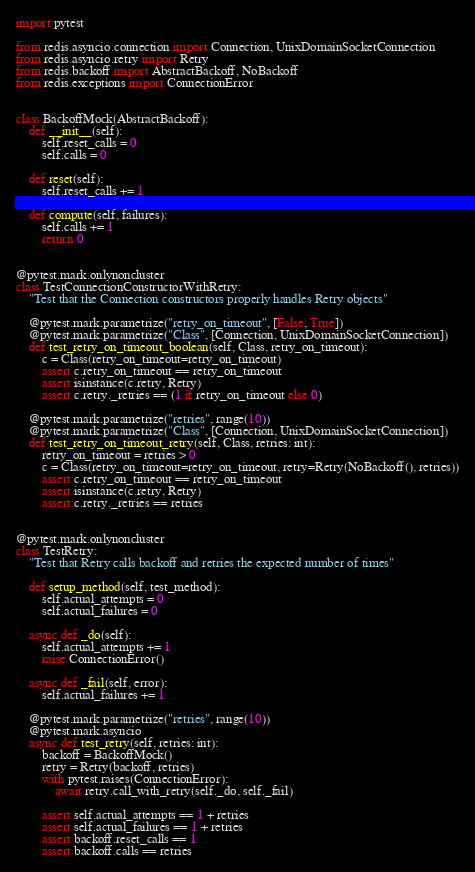<code> <loc_0><loc_0><loc_500><loc_500><_Python_>import pytest

from redis.asyncio.connection import Connection, UnixDomainSocketConnection
from redis.asyncio.retry import Retry
from redis.backoff import AbstractBackoff, NoBackoff
from redis.exceptions import ConnectionError


class BackoffMock(AbstractBackoff):
    def __init__(self):
        self.reset_calls = 0
        self.calls = 0

    def reset(self):
        self.reset_calls += 1

    def compute(self, failures):
        self.calls += 1
        return 0


@pytest.mark.onlynoncluster
class TestConnectionConstructorWithRetry:
    "Test that the Connection constructors properly handles Retry objects"

    @pytest.mark.parametrize("retry_on_timeout", [False, True])
    @pytest.mark.parametrize("Class", [Connection, UnixDomainSocketConnection])
    def test_retry_on_timeout_boolean(self, Class, retry_on_timeout):
        c = Class(retry_on_timeout=retry_on_timeout)
        assert c.retry_on_timeout == retry_on_timeout
        assert isinstance(c.retry, Retry)
        assert c.retry._retries == (1 if retry_on_timeout else 0)

    @pytest.mark.parametrize("retries", range(10))
    @pytest.mark.parametrize("Class", [Connection, UnixDomainSocketConnection])
    def test_retry_on_timeout_retry(self, Class, retries: int):
        retry_on_timeout = retries > 0
        c = Class(retry_on_timeout=retry_on_timeout, retry=Retry(NoBackoff(), retries))
        assert c.retry_on_timeout == retry_on_timeout
        assert isinstance(c.retry, Retry)
        assert c.retry._retries == retries


@pytest.mark.onlynoncluster
class TestRetry:
    "Test that Retry calls backoff and retries the expected number of times"

    def setup_method(self, test_method):
        self.actual_attempts = 0
        self.actual_failures = 0

    async def _do(self):
        self.actual_attempts += 1
        raise ConnectionError()

    async def _fail(self, error):
        self.actual_failures += 1

    @pytest.mark.parametrize("retries", range(10))
    @pytest.mark.asyncio
    async def test_retry(self, retries: int):
        backoff = BackoffMock()
        retry = Retry(backoff, retries)
        with pytest.raises(ConnectionError):
            await retry.call_with_retry(self._do, self._fail)

        assert self.actual_attempts == 1 + retries
        assert self.actual_failures == 1 + retries
        assert backoff.reset_calls == 1
        assert backoff.calls == retries
</code> 